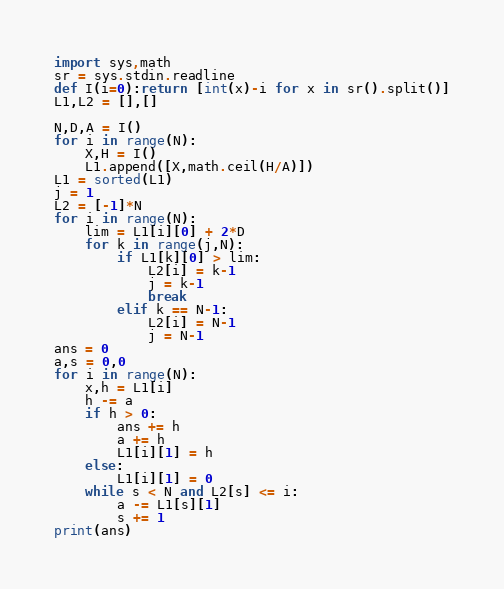Convert code to text. <code><loc_0><loc_0><loc_500><loc_500><_Python_>import sys,math
sr = sys.stdin.readline
def I(i=0):return [int(x)-i for x in sr().split()]
L1,L2 = [],[]

N,D,A = I()
for i in range(N):
    X,H = I()
    L1.append([X,math.ceil(H/A)])
L1 = sorted(L1)
j = 1
L2 = [-1]*N
for i in range(N):
    lim = L1[i][0] + 2*D
    for k in range(j,N):
        if L1[k][0] > lim:
            L2[i] = k-1
            j = k-1
            break
        elif k == N-1:
            L2[i] = N-1
            j = N-1
ans = 0
a,s = 0,0
for i in range(N):
    x,h = L1[i]
    h -= a
    if h > 0:
        ans += h
        a += h
        L1[i][1] = h
    else:
        L1[i][1] = 0
    while s < N and L2[s] <= i:
        a -= L1[s][1]
        s += 1
print(ans)</code> 